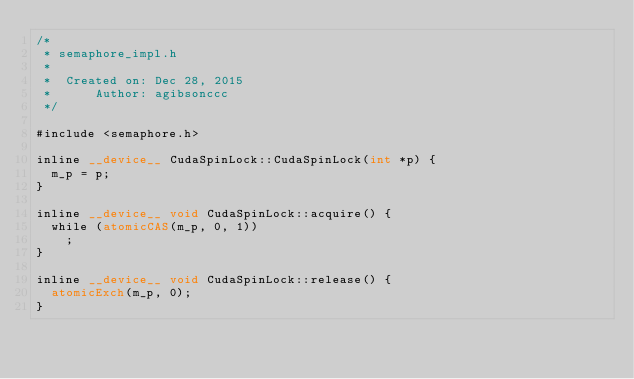<code> <loc_0><loc_0><loc_500><loc_500><_Cuda_>/*
 * semaphore_impl.h
 *
 *  Created on: Dec 28, 2015
 *      Author: agibsonccc
 */

#include <semaphore.h>

inline __device__ CudaSpinLock::CudaSpinLock(int *p) {
	m_p = p;
}

inline __device__ void CudaSpinLock::acquire() {
	while (atomicCAS(m_p, 0, 1))
		;
}

inline __device__ void CudaSpinLock::release() {
	atomicExch(m_p, 0);
}

</code> 